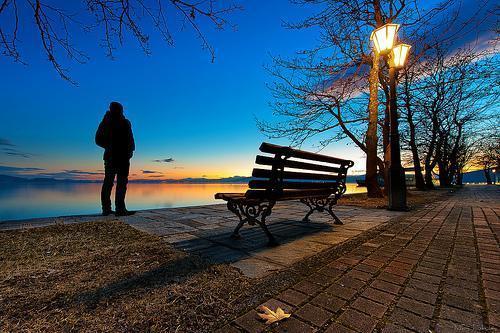How many lights are there in the picture?
Give a very brief answer. 2. 